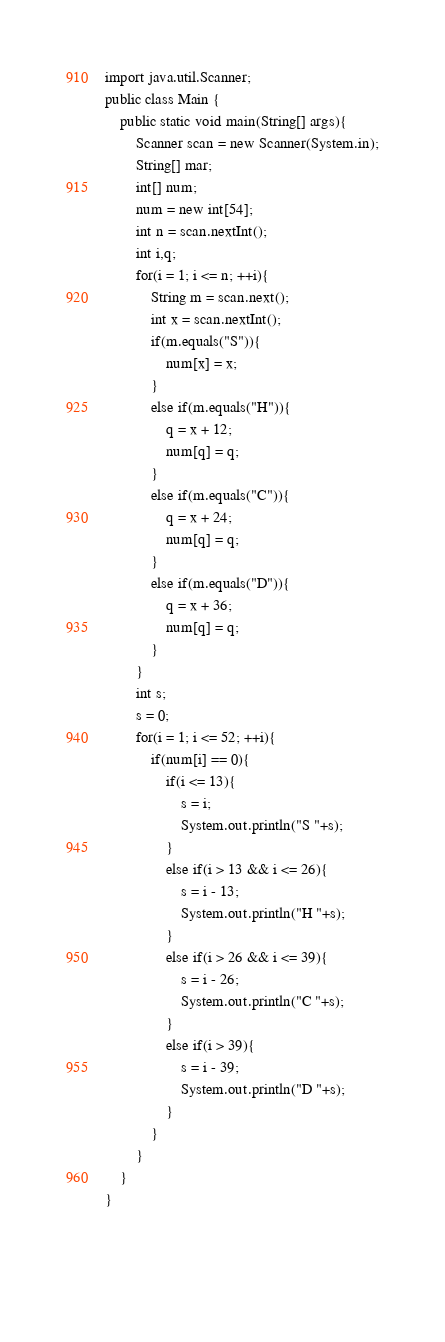<code> <loc_0><loc_0><loc_500><loc_500><_Java_>import java.util.Scanner;
public class Main {
	public static void main(String[] args){
		Scanner scan = new Scanner(System.in);
		String[] mar;
		int[] num;
		num = new int[54];
		int n = scan.nextInt();
		int i,q;
		for(i = 1; i <= n; ++i){
			String m = scan.next();
			int x = scan.nextInt();
			if(m.equals("S")){
				num[x] = x;				
			}
			else if(m.equals("H")){
				q = x + 12;
				num[q] = q;
			}
			else if(m.equals("C")){
				q = x + 24;
				num[q] = q;
			}
			else if(m.equals("D")){
				q = x + 36;
				num[q] = q;
			}	
		}
		int s;
		s = 0;
		for(i = 1; i <= 52; ++i){
			if(num[i] == 0){
				if(i <= 13){
					s = i;
					System.out.println("S "+s);
				}
				else if(i > 13 && i <= 26){
					s = i - 13;
					System.out.println("H "+s);
				}
				else if(i > 26 && i <= 39){
					s = i - 26;
					System.out.println("C "+s);
				}
				else if(i > 39){
					s = i - 39;
					System.out.println("D "+s);
				}
			}
		}
	}
}

		
				</code> 